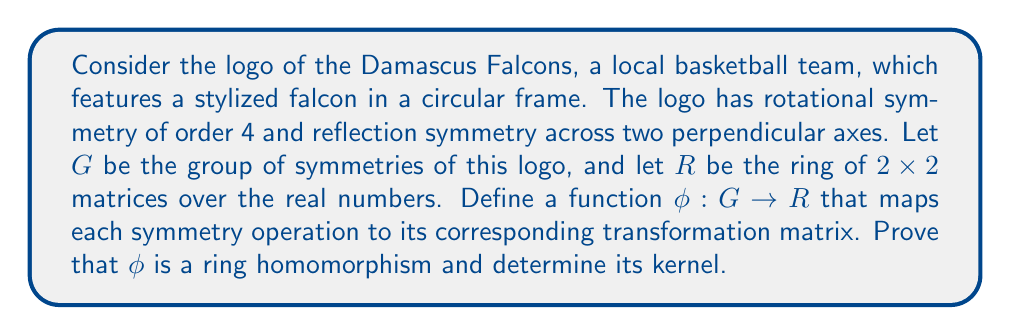Can you solve this math problem? To approach this problem, we'll follow these steps:

1) First, let's identify the elements of the group $G$. Given the symmetries described, $G$ is isomorphic to the dihedral group $D_4$, which has 8 elements: 4 rotations (including the identity) and 4 reflections.

2) Now, let's define $\phi$. For each symmetry in $G$, we need to assign a $2 \times 2$ matrix that represents that transformation:

   - Identity: $\phi(e) = \begin{pmatrix} 1 & 0 \\ 0 & 1 \end{pmatrix}$
   - 90° rotation: $\phi(r) = \begin{pmatrix} 0 & -1 \\ 1 & 0 \end{pmatrix}$
   - 180° rotation: $\phi(r^2) = \begin{pmatrix} -1 & 0 \\ 0 & -1 \end{pmatrix}$
   - 270° rotation: $\phi(r^3) = \begin{pmatrix} 0 & 1 \\ -1 & 0 \end{pmatrix}$
   - Reflection across x-axis: $\phi(s_x) = \begin{pmatrix} 1 & 0 \\ 0 & -1 \end{pmatrix}$
   - Reflection across y-axis: $\phi(s_y) = \begin{pmatrix} -1 & 0 \\ 0 & 1 \end{pmatrix}$
   - Reflection across y=x: $\phi(s_{y=x}) = \begin{pmatrix} 0 & 1 \\ 1 & 0 \end{pmatrix}$
   - Reflection across y=-x: $\phi(s_{y=-x}) = \begin{pmatrix} 0 & -1 \\ -1 & 0 \end{pmatrix}$

3) To prove that $\phi$ is a ring homomorphism, we need to show:
   a) $\phi(a + b) = \phi(a) + \phi(b)$ for all $a, b \in G$
   b) $\phi(ab) = \phi(a)\phi(b)$ for all $a, b \in G$

   For a), note that addition is not defined in $G$, so this condition is vacuously true.

   For b), we can verify this by checking all possible combinations of elements in $G$. For example:
   $\phi(r \cdot s_x) = \phi(s_{y=-x}) = \begin{pmatrix} 0 & -1 \\ -1 & 0 \end{pmatrix}$
   $\phi(r)\phi(s_x) = \begin{pmatrix} 0 & -1 \\ 1 & 0 \end{pmatrix}\begin{pmatrix} 1 & 0 \\ 0 & -1 \end{pmatrix} = \begin{pmatrix} 0 & -1 \\ -1 & 0 \end{pmatrix}$

   This holds for all combinations, proving that $\phi$ is a ring homomorphism.

4) To find the kernel of $\phi$, we need to identify all elements of $G$ that map to the identity matrix in $R$:

   $\ker(\phi) = \{g \in G : \phi(g) = \begin{pmatrix} 1 & 0 \\ 0 & 1 \end{pmatrix}\}$

   From our mapping, we can see that only the identity element of $G$ maps to the identity matrix in $R$.

Therefore, $\ker(\phi) = \{e\}$, where $e$ is the identity element of $G$.
Answer: $\phi$ is a ring homomorphism, and $\ker(\phi) = \{e\}$, where $e$ is the identity element of $G$. 